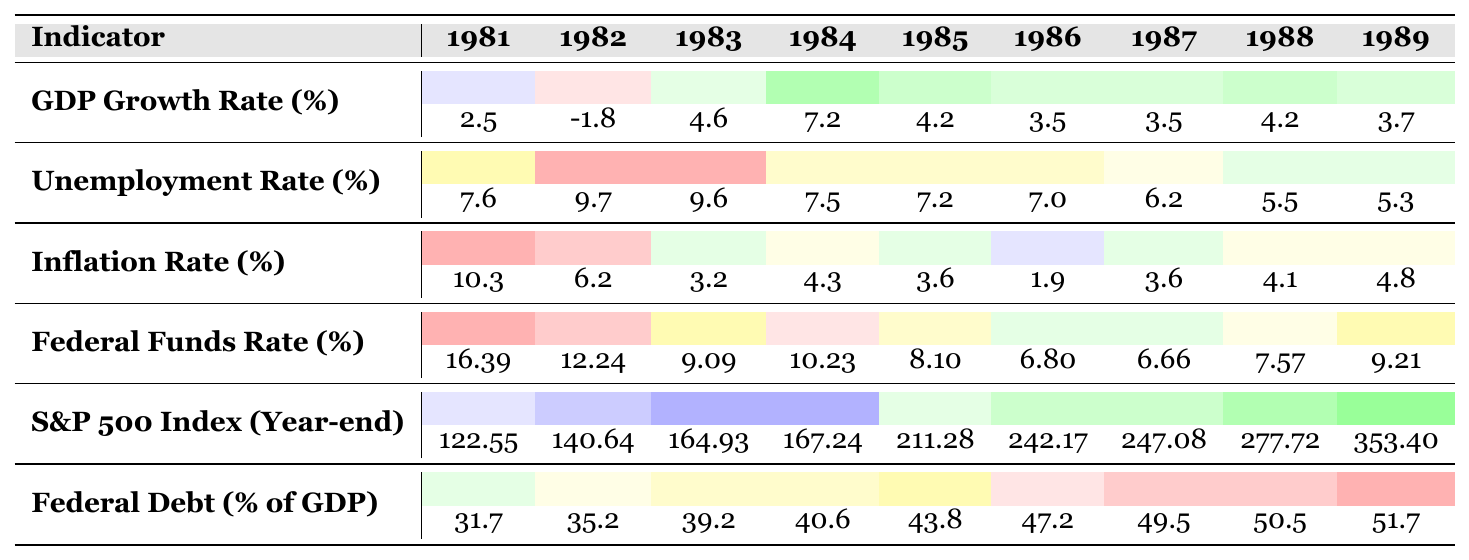What was the GDP growth rate in 1982? The table shows that the GDP growth rate for the year 1982 is recorded as -1.8% in the respective column.
Answer: -1.8% Which year had the highest unemployment rate? Reviewing the unemployment rate values, 1982 has the highest rate of 9.7%, compared to other years listed.
Answer: 1982 What was the inflation rate in 1986? Looking at the inflation rate for 1986 in the table, it is found to be 1.9%.
Answer: 1.9% What is the difference in GDP growth rate between 1984 and 1983? The GDP growth rate for 1984 is 7.2% and for 1983 is 4.6%. Subtracting gives: 7.2% - 4.6% = 2.6%.
Answer: 2.6% What was the average unemployment rate during the Reagan years? Adding the unemployment rates from each year (7.6 + 9.7 + 9.6 + 7.5 + 7.2 + 7.0 + 6.2 + 5.5 + 5.3) gives a sum of 60.6. There are 9 years, so the average is 60.6 / 9 = 6.73%.
Answer: 6.73% Did the S&P 500 Index increase every year from 1981 to 1989? The table indicates that the S&P 500 index values increased each year, moving from 122.55 in 1981 to 353.40 in 1989 without any decreases.
Answer: Yes What year experienced the lowest federal funds rate? A review of the federal funds rates shows the lowest value is 6.66% in 1987, which is noted in the table.
Answer: 1987 If we categorize GDP growth rates into low (below 2%), moderate (2-5%), and high (above 5%), how many years were categorized as high during Reagan's presidency? Looking at the GDP growth figures, the years 1984 (7.2%) and 1984 (7.2%) fall into the high category, totaling 2 years.
Answer: 2 What was the percentage increase in the S&P 500 index from 1988 to 1989? The S&P 500 index increased from 277.72 in 1988 to 353.40 in 1989. The increase is 353.40 - 277.72 = 75.68. To find the percentage increase, calculate (75.68 / 277.72) * 100 = 27.26%.
Answer: 27.26% What was the trend in inflation rates from 1981 to 1983? The inflation rates decreased from 10.3% in 1981 to 6.2% in 1982, and then further down to 3.2% in 1983, indicating a decreasing trend over these three years.
Answer: Decreasing trend In what year did federal debt as a percentage of GDP first exceed 40%? The table shows that federal debt exceeded 40% in the year 1984 at 40.6%, marking the first occurrence over that threshold.
Answer: 1984 